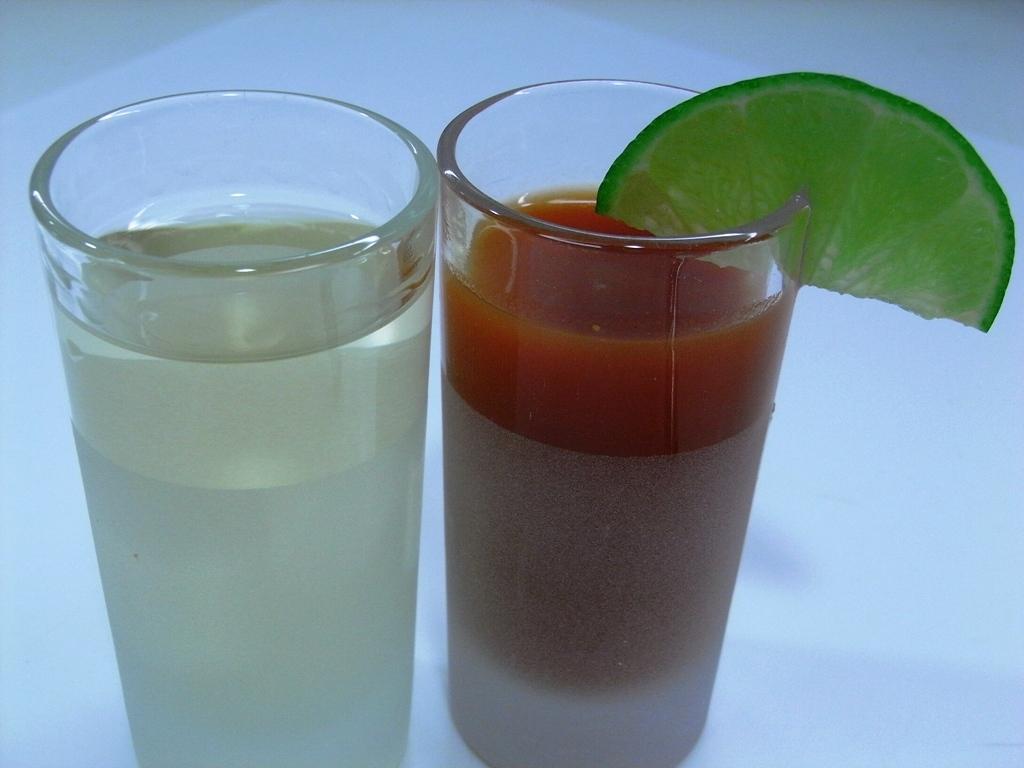Describe this image in one or two sentences. In this image we can see beverage glasses and a lemon wedge to one of the glasses. 